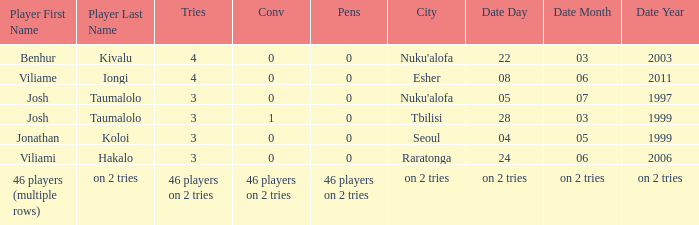What date did Josh Taumalolo play at Nuku'alofa? 05/07/1997. 